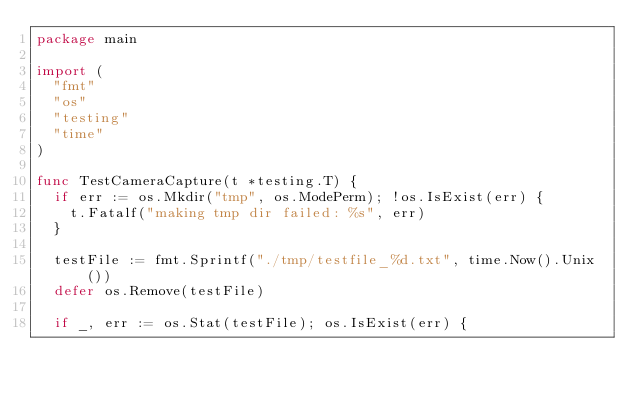Convert code to text. <code><loc_0><loc_0><loc_500><loc_500><_Go_>package main

import (
	"fmt"
	"os"
	"testing"
	"time"
)

func TestCameraCapture(t *testing.T) {
	if err := os.Mkdir("tmp", os.ModePerm); !os.IsExist(err) {
		t.Fatalf("making tmp dir failed: %s", err)
	}

	testFile := fmt.Sprintf("./tmp/testfile_%d.txt", time.Now().Unix())
	defer os.Remove(testFile)

	if _, err := os.Stat(testFile); os.IsExist(err) {</code> 